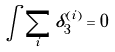<formula> <loc_0><loc_0><loc_500><loc_500>\int \sum _ { i } \delta ^ { ( i ) } _ { 3 } = 0</formula> 